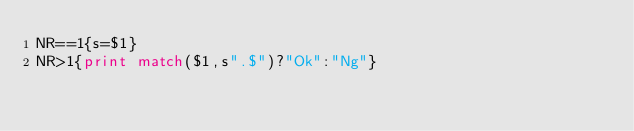<code> <loc_0><loc_0><loc_500><loc_500><_Awk_>NR==1{s=$1}
NR>1{print match($1,s".$")?"Ok":"Ng"}
</code> 